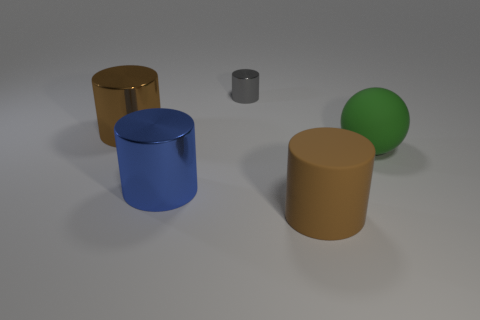Subtract all large cylinders. How many cylinders are left? 1 Subtract all red cubes. How many brown cylinders are left? 2 Subtract all gray cylinders. How many cylinders are left? 3 Add 5 purple blocks. How many objects exist? 10 Subtract 2 cylinders. How many cylinders are left? 2 Subtract all balls. How many objects are left? 4 Subtract all red cylinders. Subtract all green spheres. How many cylinders are left? 4 Add 4 tiny gray objects. How many tiny gray objects are left? 5 Add 5 tiny cylinders. How many tiny cylinders exist? 6 Subtract 0 brown cubes. How many objects are left? 5 